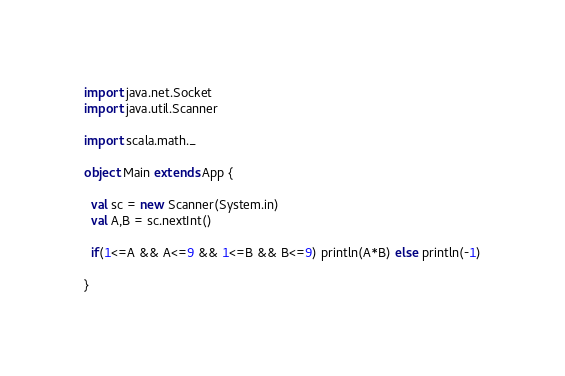Convert code to text. <code><loc_0><loc_0><loc_500><loc_500><_Scala_>import java.net.Socket
import java.util.Scanner

import scala.math._

object Main extends App {

  val sc = new Scanner(System.in)
  val A,B = sc.nextInt()

  if(1<=A && A<=9 && 1<=B && B<=9) println(A*B) else println(-1)

}


</code> 